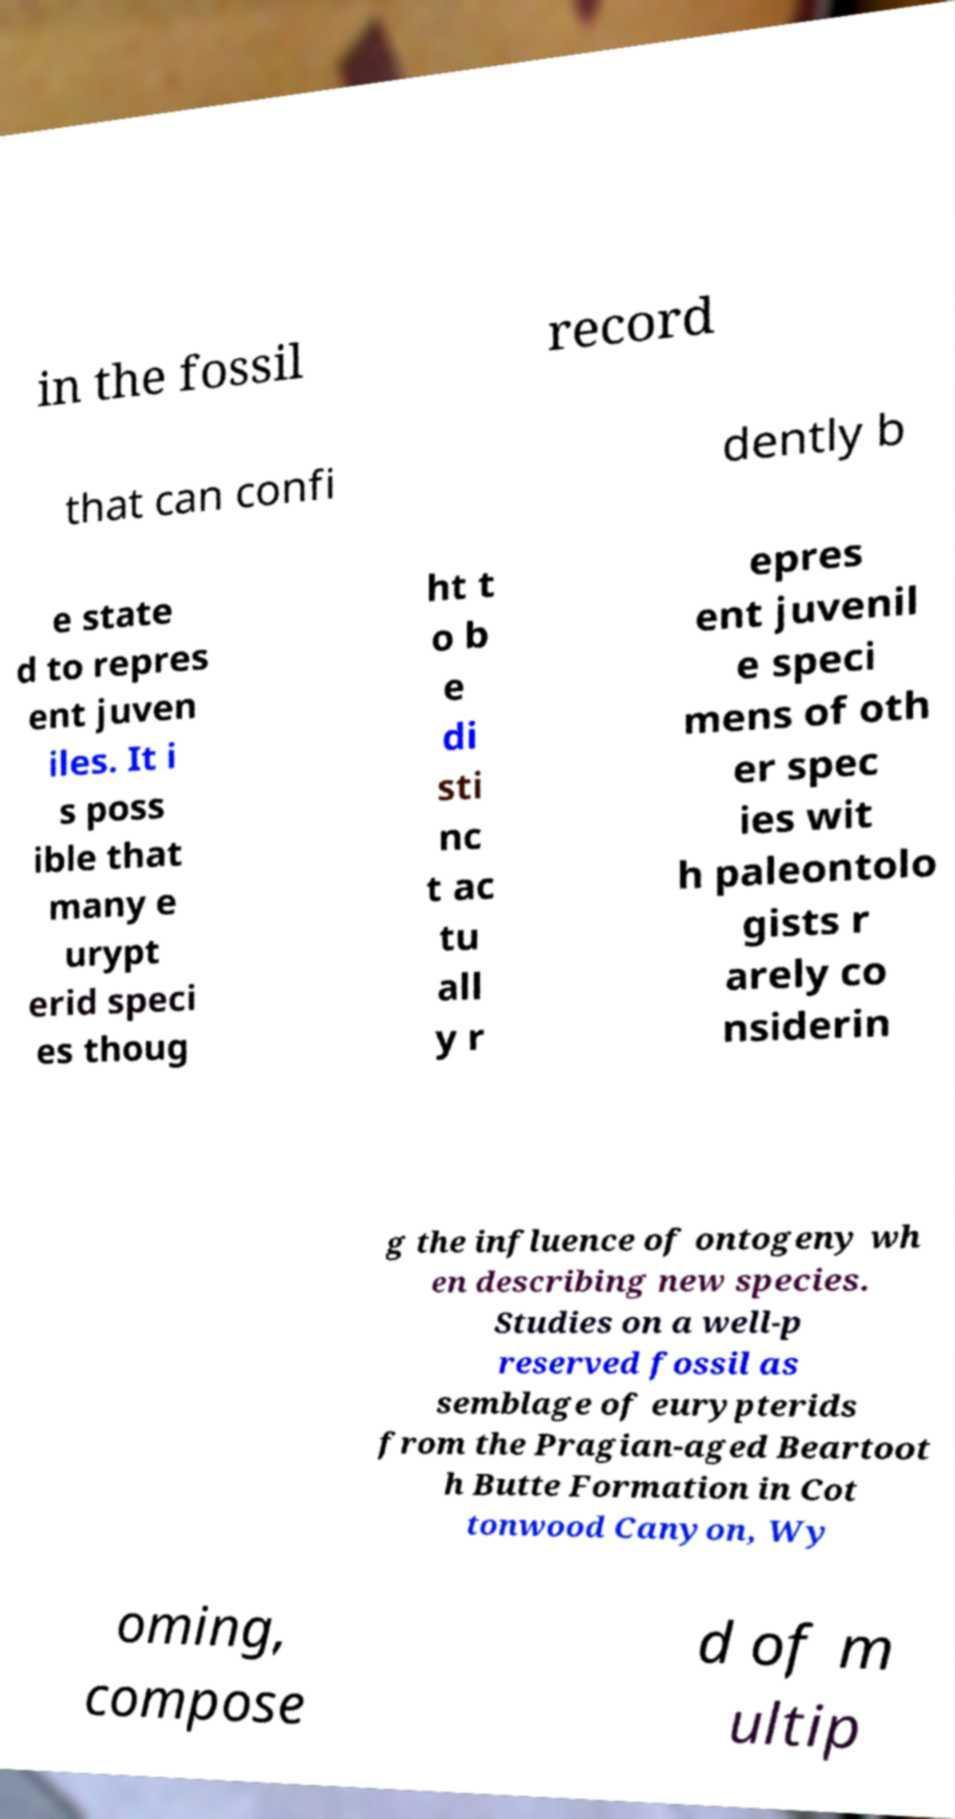There's text embedded in this image that I need extracted. Can you transcribe it verbatim? in the fossil record that can confi dently b e state d to repres ent juven iles. It i s poss ible that many e urypt erid speci es thoug ht t o b e di sti nc t ac tu all y r epres ent juvenil e speci mens of oth er spec ies wit h paleontolo gists r arely co nsiderin g the influence of ontogeny wh en describing new species. Studies on a well-p reserved fossil as semblage of eurypterids from the Pragian-aged Beartoot h Butte Formation in Cot tonwood Canyon, Wy oming, compose d of m ultip 